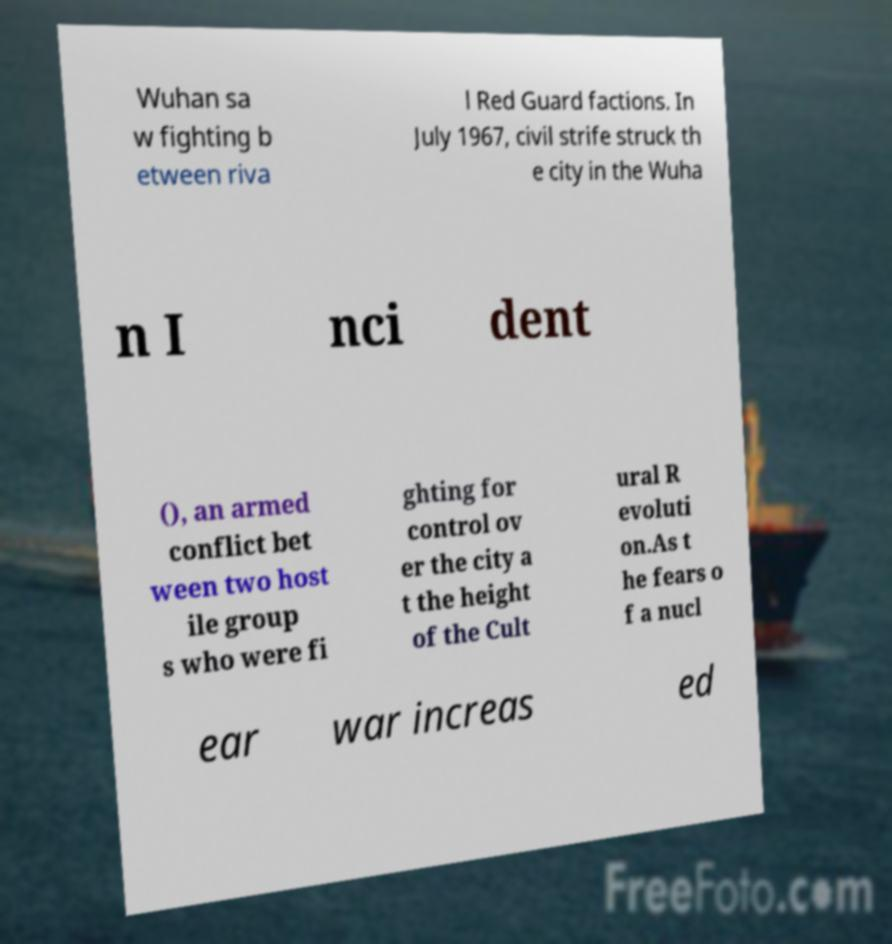What messages or text are displayed in this image? I need them in a readable, typed format. Wuhan sa w fighting b etween riva l Red Guard factions. In July 1967, civil strife struck th e city in the Wuha n I nci dent (), an armed conflict bet ween two host ile group s who were fi ghting for control ov er the city a t the height of the Cult ural R evoluti on.As t he fears o f a nucl ear war increas ed 